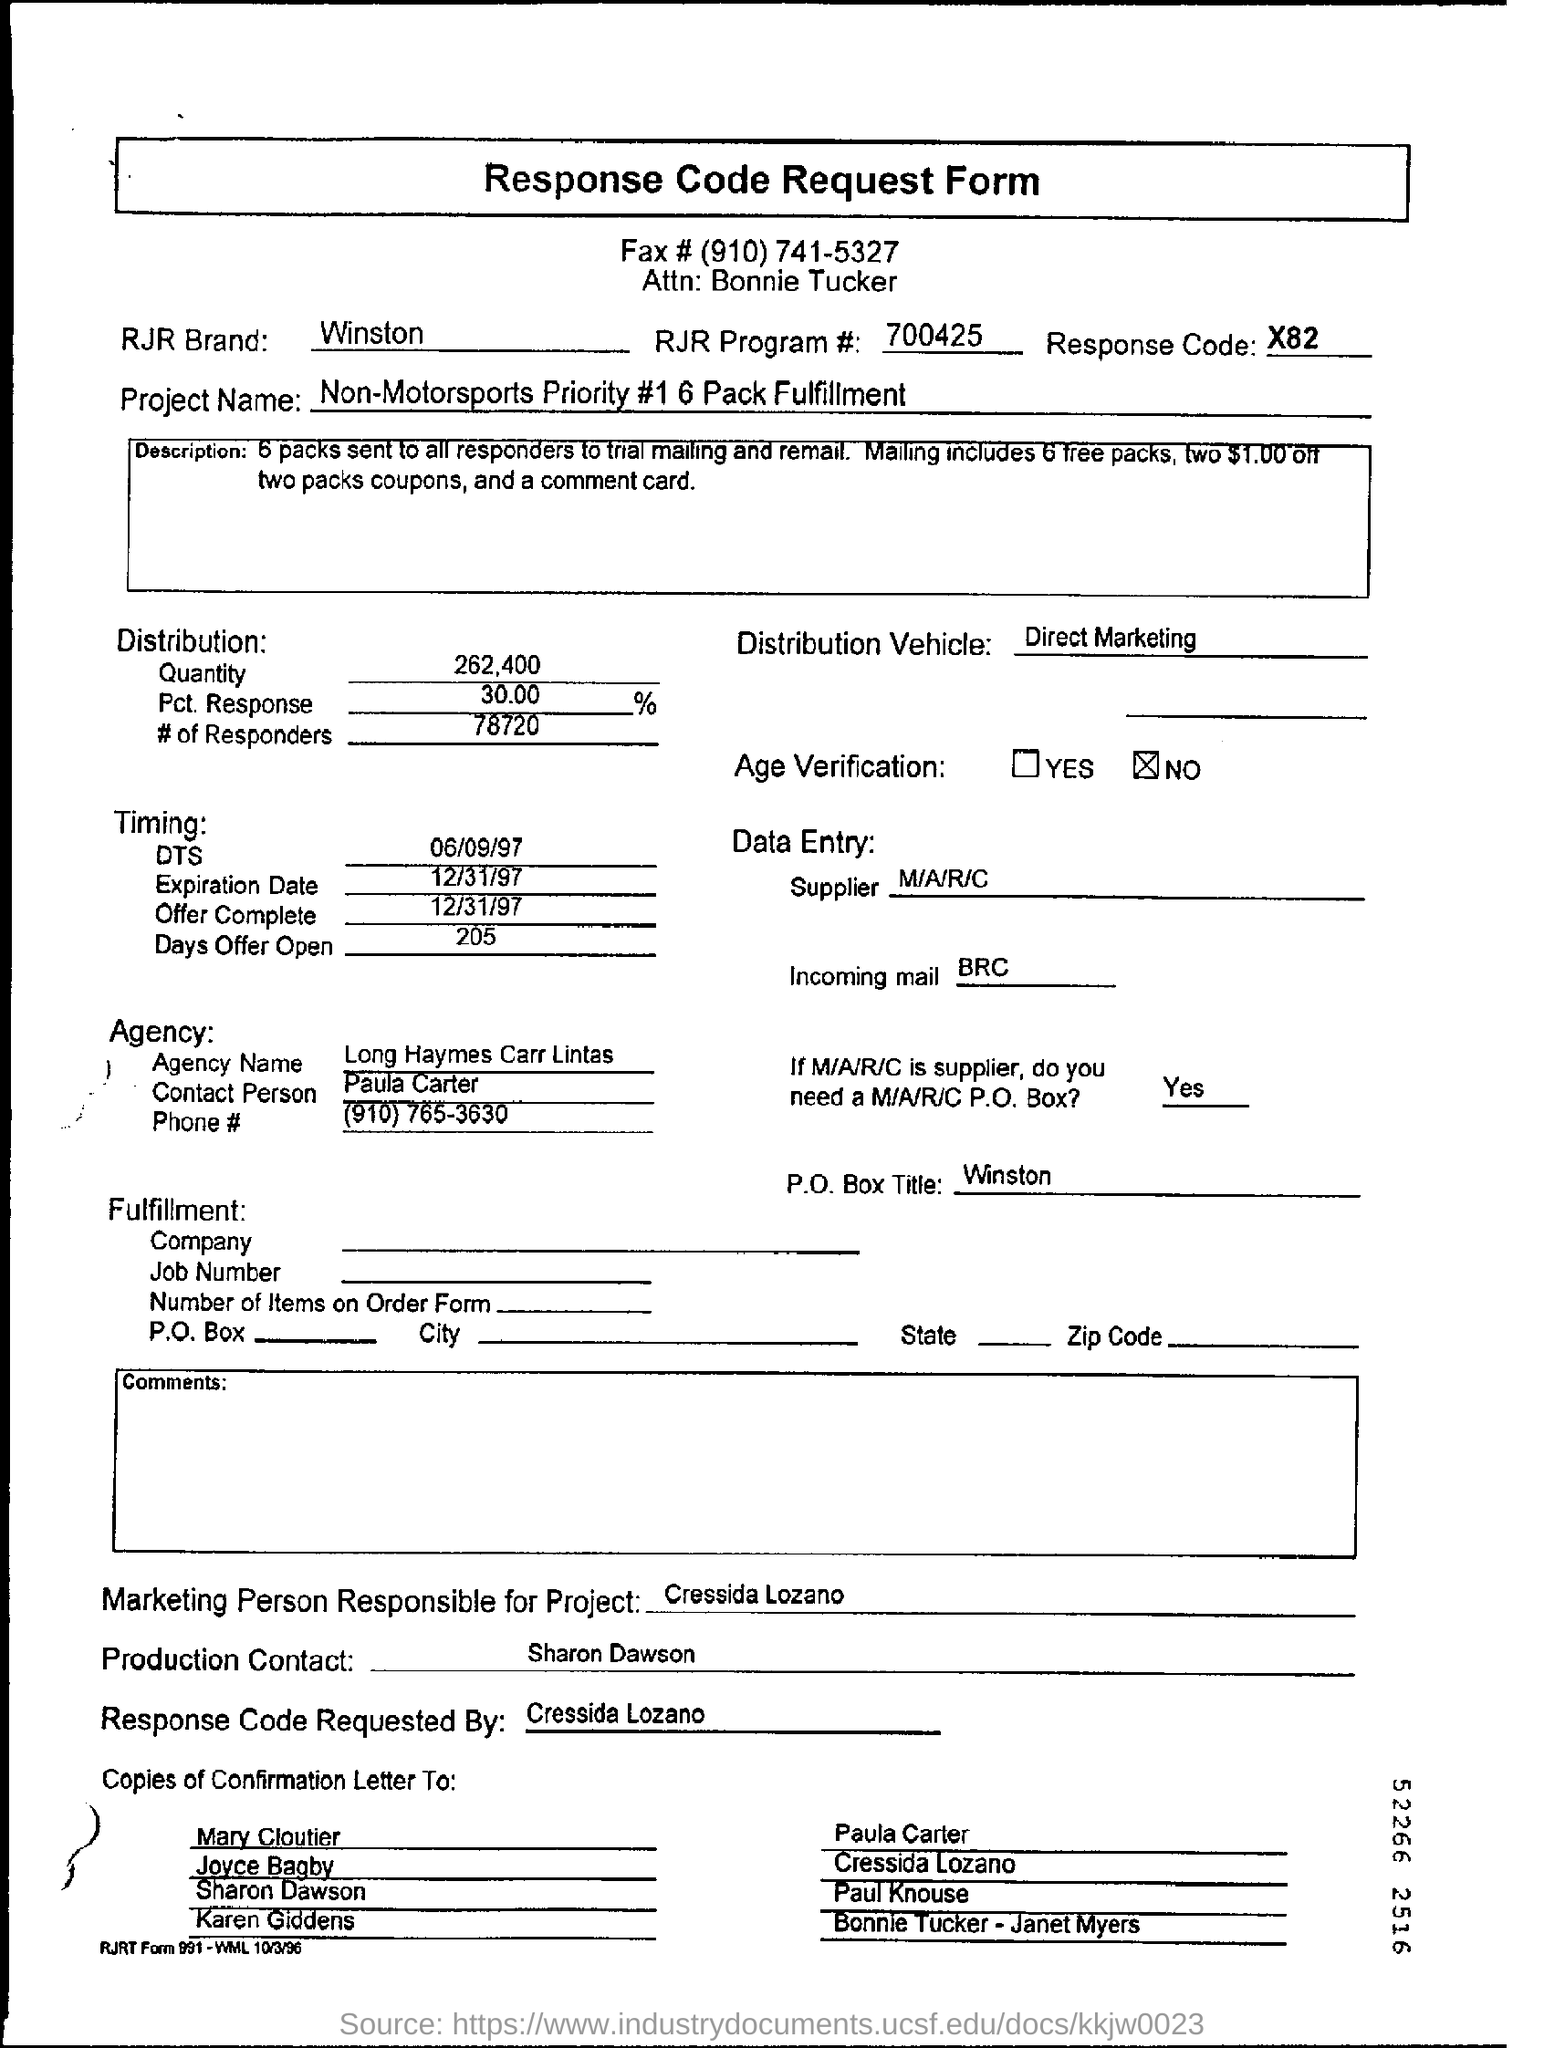What is  the RJR Program #?
Keep it short and to the point. 700425. What is the Project Name?
Ensure brevity in your answer.  Non-Motorsports Priority #1. What is the Distribution Vehicle?
Make the answer very short. Direct  Marketing. Who is the Contact Person of the Agency?
Your response must be concise. Paula Carter. What is the P. O. Box Title?
Ensure brevity in your answer.  Winston. 